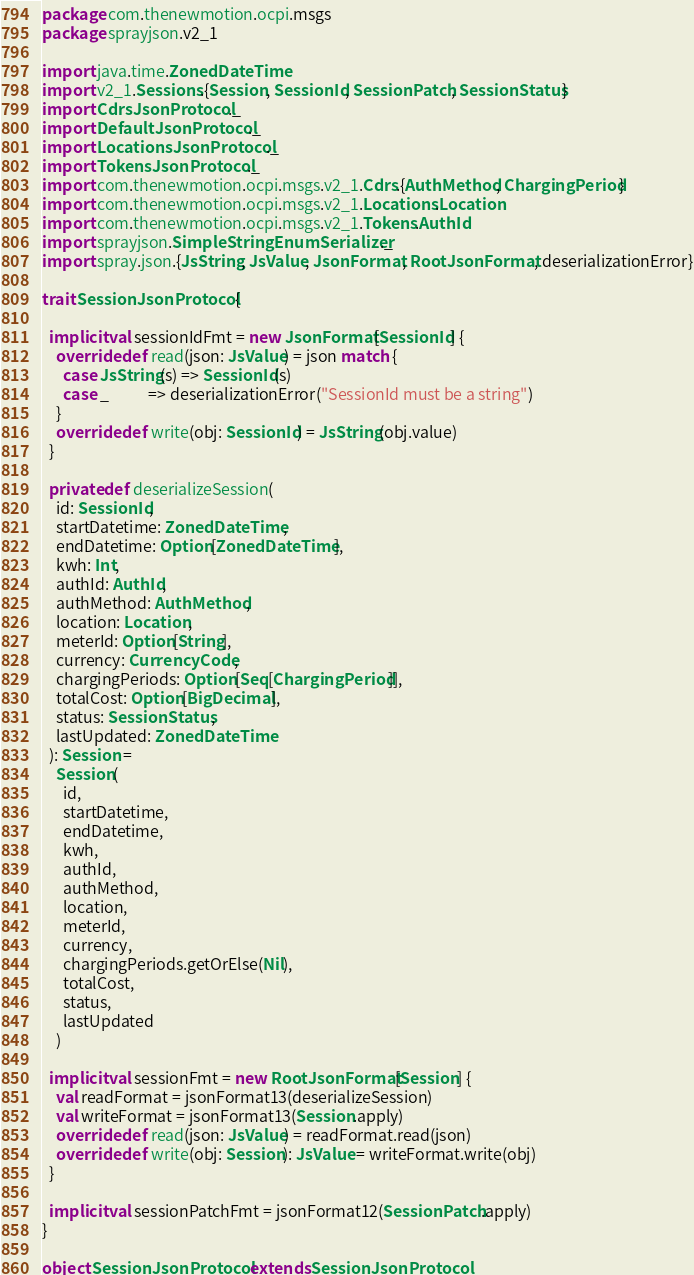Convert code to text. <code><loc_0><loc_0><loc_500><loc_500><_Scala_>package com.thenewmotion.ocpi.msgs
package sprayjson.v2_1

import java.time.ZonedDateTime
import v2_1.Sessions.{Session, SessionId, SessionPatch, SessionStatus}
import CdrsJsonProtocol._
import DefaultJsonProtocol._
import LocationsJsonProtocol._
import TokensJsonProtocol._
import com.thenewmotion.ocpi.msgs.v2_1.Cdrs.{AuthMethod, ChargingPeriod}
import com.thenewmotion.ocpi.msgs.v2_1.Locations.Location
import com.thenewmotion.ocpi.msgs.v2_1.Tokens.AuthId
import sprayjson.SimpleStringEnumSerializer._
import spray.json.{JsString, JsValue, JsonFormat, RootJsonFormat, deserializationError}

trait SessionJsonProtocol {

  implicit val sessionIdFmt = new JsonFormat[SessionId] {
    override def read(json: JsValue) = json match {
      case JsString(s) => SessionId(s)
      case _           => deserializationError("SessionId must be a string")
    }
    override def write(obj: SessionId) = JsString(obj.value)
  }

  private def deserializeSession(
    id: SessionId,
    startDatetime: ZonedDateTime,
    endDatetime: Option[ZonedDateTime],
    kwh: Int,
    authId: AuthId,
    authMethod: AuthMethod,
    location: Location,
    meterId: Option[String],
    currency: CurrencyCode,
    chargingPeriods: Option[Seq[ChargingPeriod]],
    totalCost: Option[BigDecimal],
    status: SessionStatus,
    lastUpdated: ZonedDateTime
  ): Session =
    Session(
      id,
      startDatetime,
      endDatetime,
      kwh,
      authId,
      authMethod,
      location,
      meterId,
      currency,
      chargingPeriods.getOrElse(Nil),
      totalCost,
      status,
      lastUpdated
    )

  implicit val sessionFmt = new RootJsonFormat[Session] {
    val readFormat = jsonFormat13(deserializeSession)
    val writeFormat = jsonFormat13(Session.apply)
    override def read(json: JsValue) = readFormat.read(json)
    override def write(obj: Session): JsValue = writeFormat.write(obj)
  }

  implicit val sessionPatchFmt = jsonFormat12(SessionPatch.apply)
}

object SessionJsonProtocol extends SessionJsonProtocol
</code> 